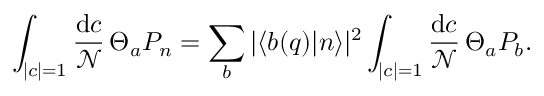Convert formula to latex. <formula><loc_0><loc_0><loc_500><loc_500>\int _ { | c | = 1 } { \frac { d c } { \mathcal { N } } } \, \Theta _ { a } P _ { n } = \sum _ { b } | \langle b ( q ) | n \rangle | ^ { 2 } \int _ { | c | = 1 } { \frac { d c } { \mathcal { N } } } \, \Theta _ { a } P _ { b } .</formula> 